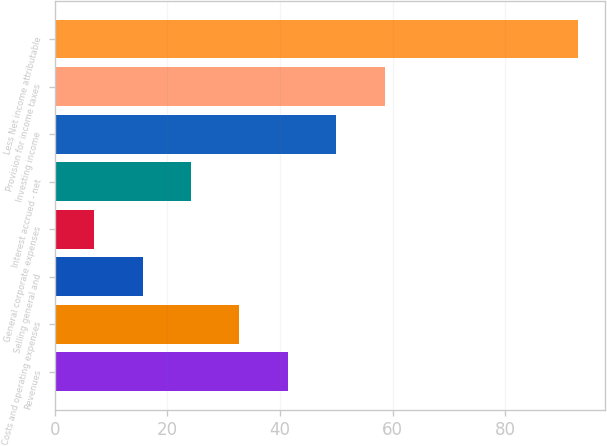<chart> <loc_0><loc_0><loc_500><loc_500><bar_chart><fcel>Revenues<fcel>Costs and operating expenses<fcel>Selling general and<fcel>General corporate expenses<fcel>Interest accrued - net<fcel>Investing income<fcel>Provision for income taxes<fcel>Less Net income attributable<nl><fcel>41.4<fcel>32.8<fcel>15.6<fcel>7<fcel>24.2<fcel>50<fcel>58.6<fcel>93<nl></chart> 